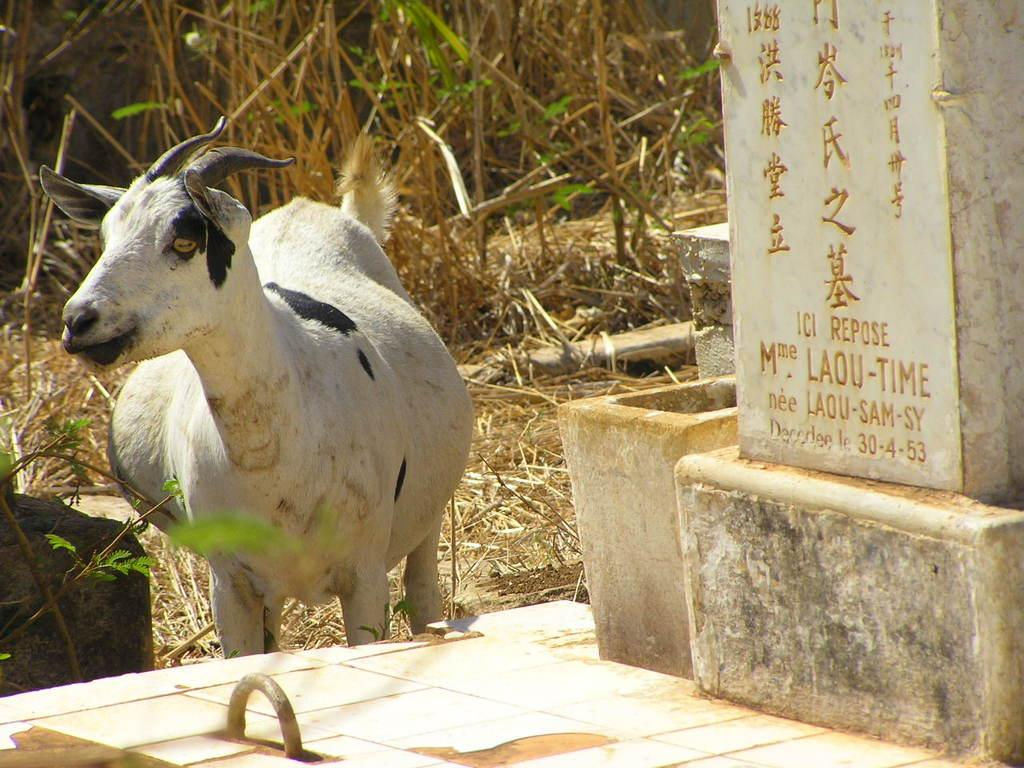What animal is standing in the image? There is a goat standing in the image. What object with letters can be seen in the image? There is a stone with letters carved on it in the image. What type of vegetation is visible in the image? Dried grass is visible in the image. How many beads are hanging from the goat's neck in the image? There are no beads present in the image; the goat is not wearing any necklaces or accessories. 